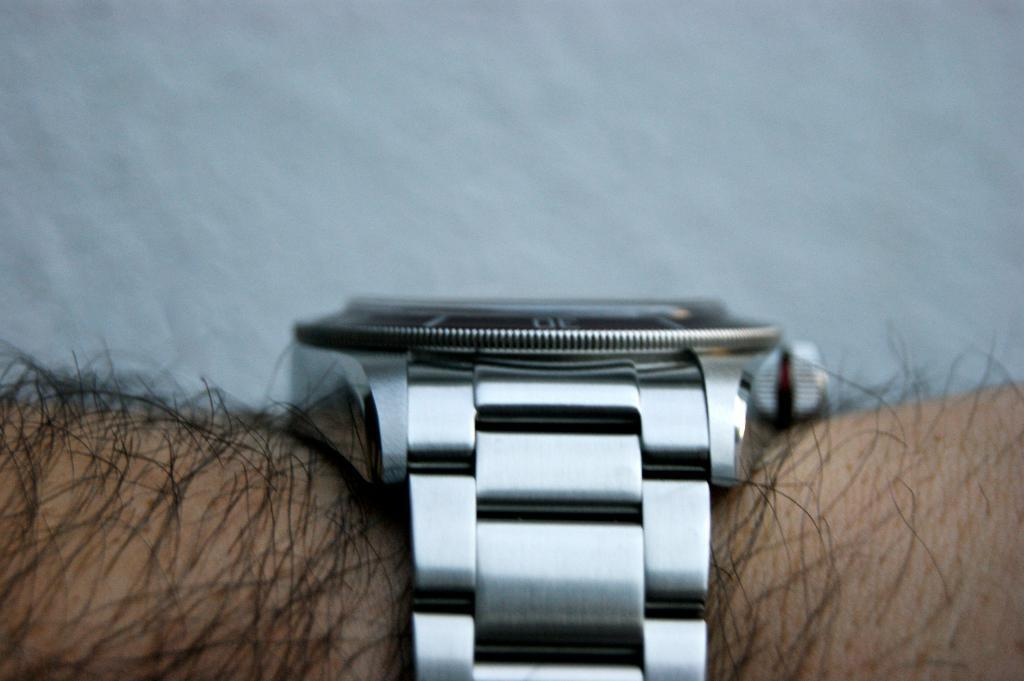What is the main subject of the image? There is a person in the image. Can you describe any accessories the person is wearing? The person is wearing a watch. What is the position of the art in the image? There is no art present in the image, so it is not possible to determine its position. 